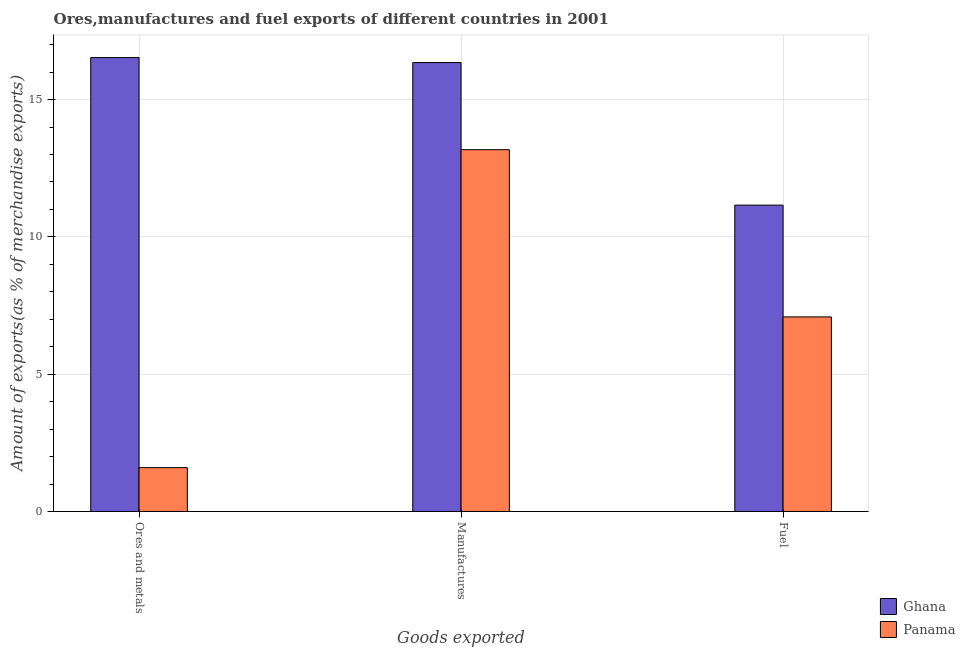How many different coloured bars are there?
Your answer should be compact. 2. How many groups of bars are there?
Ensure brevity in your answer.  3. Are the number of bars on each tick of the X-axis equal?
Offer a terse response. Yes. How many bars are there on the 1st tick from the left?
Your answer should be very brief. 2. What is the label of the 1st group of bars from the left?
Provide a succinct answer. Ores and metals. What is the percentage of manufactures exports in Panama?
Provide a short and direct response. 13.18. Across all countries, what is the maximum percentage of ores and metals exports?
Make the answer very short. 16.53. Across all countries, what is the minimum percentage of manufactures exports?
Offer a very short reply. 13.18. In which country was the percentage of fuel exports minimum?
Offer a terse response. Panama. What is the total percentage of ores and metals exports in the graph?
Offer a terse response. 18.13. What is the difference between the percentage of ores and metals exports in Panama and that in Ghana?
Your answer should be compact. -14.93. What is the difference between the percentage of fuel exports in Ghana and the percentage of ores and metals exports in Panama?
Offer a terse response. 9.56. What is the average percentage of ores and metals exports per country?
Make the answer very short. 9.06. What is the difference between the percentage of fuel exports and percentage of ores and metals exports in Panama?
Your answer should be very brief. 5.49. In how many countries, is the percentage of fuel exports greater than 8 %?
Your answer should be very brief. 1. What is the ratio of the percentage of ores and metals exports in Ghana to that in Panama?
Make the answer very short. 10.35. Is the difference between the percentage of manufactures exports in Panama and Ghana greater than the difference between the percentage of fuel exports in Panama and Ghana?
Offer a very short reply. Yes. What is the difference between the highest and the second highest percentage of ores and metals exports?
Provide a succinct answer. 14.93. What is the difference between the highest and the lowest percentage of ores and metals exports?
Offer a terse response. 14.93. In how many countries, is the percentage of ores and metals exports greater than the average percentage of ores and metals exports taken over all countries?
Offer a very short reply. 1. Is the sum of the percentage of manufactures exports in Panama and Ghana greater than the maximum percentage of fuel exports across all countries?
Keep it short and to the point. Yes. What does the 2nd bar from the left in Fuel represents?
Give a very brief answer. Panama. Is it the case that in every country, the sum of the percentage of ores and metals exports and percentage of manufactures exports is greater than the percentage of fuel exports?
Make the answer very short. Yes. Are all the bars in the graph horizontal?
Make the answer very short. No. How many countries are there in the graph?
Make the answer very short. 2. What is the difference between two consecutive major ticks on the Y-axis?
Your answer should be compact. 5. Are the values on the major ticks of Y-axis written in scientific E-notation?
Your response must be concise. No. How many legend labels are there?
Offer a very short reply. 2. What is the title of the graph?
Offer a very short reply. Ores,manufactures and fuel exports of different countries in 2001. Does "Chile" appear as one of the legend labels in the graph?
Offer a very short reply. No. What is the label or title of the X-axis?
Provide a short and direct response. Goods exported. What is the label or title of the Y-axis?
Keep it short and to the point. Amount of exports(as % of merchandise exports). What is the Amount of exports(as % of merchandise exports) of Ghana in Ores and metals?
Your answer should be compact. 16.53. What is the Amount of exports(as % of merchandise exports) of Panama in Ores and metals?
Your answer should be very brief. 1.6. What is the Amount of exports(as % of merchandise exports) in Ghana in Manufactures?
Offer a terse response. 16.35. What is the Amount of exports(as % of merchandise exports) in Panama in Manufactures?
Ensure brevity in your answer.  13.18. What is the Amount of exports(as % of merchandise exports) in Ghana in Fuel?
Give a very brief answer. 11.16. What is the Amount of exports(as % of merchandise exports) of Panama in Fuel?
Provide a succinct answer. 7.09. Across all Goods exported, what is the maximum Amount of exports(as % of merchandise exports) in Ghana?
Offer a very short reply. 16.53. Across all Goods exported, what is the maximum Amount of exports(as % of merchandise exports) in Panama?
Your response must be concise. 13.18. Across all Goods exported, what is the minimum Amount of exports(as % of merchandise exports) in Ghana?
Your answer should be very brief. 11.16. Across all Goods exported, what is the minimum Amount of exports(as % of merchandise exports) of Panama?
Give a very brief answer. 1.6. What is the total Amount of exports(as % of merchandise exports) in Ghana in the graph?
Your answer should be very brief. 44.03. What is the total Amount of exports(as % of merchandise exports) in Panama in the graph?
Your response must be concise. 21.86. What is the difference between the Amount of exports(as % of merchandise exports) of Ghana in Ores and metals and that in Manufactures?
Offer a terse response. 0.18. What is the difference between the Amount of exports(as % of merchandise exports) in Panama in Ores and metals and that in Manufactures?
Your answer should be very brief. -11.58. What is the difference between the Amount of exports(as % of merchandise exports) of Ghana in Ores and metals and that in Fuel?
Your answer should be compact. 5.37. What is the difference between the Amount of exports(as % of merchandise exports) in Panama in Ores and metals and that in Fuel?
Your response must be concise. -5.49. What is the difference between the Amount of exports(as % of merchandise exports) in Ghana in Manufactures and that in Fuel?
Make the answer very short. 5.19. What is the difference between the Amount of exports(as % of merchandise exports) in Panama in Manufactures and that in Fuel?
Your answer should be compact. 6.09. What is the difference between the Amount of exports(as % of merchandise exports) in Ghana in Ores and metals and the Amount of exports(as % of merchandise exports) in Panama in Manufactures?
Ensure brevity in your answer.  3.35. What is the difference between the Amount of exports(as % of merchandise exports) in Ghana in Ores and metals and the Amount of exports(as % of merchandise exports) in Panama in Fuel?
Your response must be concise. 9.44. What is the difference between the Amount of exports(as % of merchandise exports) of Ghana in Manufactures and the Amount of exports(as % of merchandise exports) of Panama in Fuel?
Keep it short and to the point. 9.26. What is the average Amount of exports(as % of merchandise exports) in Ghana per Goods exported?
Offer a terse response. 14.68. What is the average Amount of exports(as % of merchandise exports) in Panama per Goods exported?
Your response must be concise. 7.29. What is the difference between the Amount of exports(as % of merchandise exports) of Ghana and Amount of exports(as % of merchandise exports) of Panama in Ores and metals?
Offer a terse response. 14.93. What is the difference between the Amount of exports(as % of merchandise exports) of Ghana and Amount of exports(as % of merchandise exports) of Panama in Manufactures?
Provide a succinct answer. 3.17. What is the difference between the Amount of exports(as % of merchandise exports) in Ghana and Amount of exports(as % of merchandise exports) in Panama in Fuel?
Keep it short and to the point. 4.07. What is the ratio of the Amount of exports(as % of merchandise exports) of Ghana in Ores and metals to that in Manufactures?
Make the answer very short. 1.01. What is the ratio of the Amount of exports(as % of merchandise exports) of Panama in Ores and metals to that in Manufactures?
Offer a terse response. 0.12. What is the ratio of the Amount of exports(as % of merchandise exports) of Ghana in Ores and metals to that in Fuel?
Ensure brevity in your answer.  1.48. What is the ratio of the Amount of exports(as % of merchandise exports) of Panama in Ores and metals to that in Fuel?
Your response must be concise. 0.23. What is the ratio of the Amount of exports(as % of merchandise exports) in Ghana in Manufactures to that in Fuel?
Your response must be concise. 1.47. What is the ratio of the Amount of exports(as % of merchandise exports) of Panama in Manufactures to that in Fuel?
Give a very brief answer. 1.86. What is the difference between the highest and the second highest Amount of exports(as % of merchandise exports) in Ghana?
Offer a very short reply. 0.18. What is the difference between the highest and the second highest Amount of exports(as % of merchandise exports) of Panama?
Ensure brevity in your answer.  6.09. What is the difference between the highest and the lowest Amount of exports(as % of merchandise exports) of Ghana?
Ensure brevity in your answer.  5.37. What is the difference between the highest and the lowest Amount of exports(as % of merchandise exports) of Panama?
Provide a succinct answer. 11.58. 